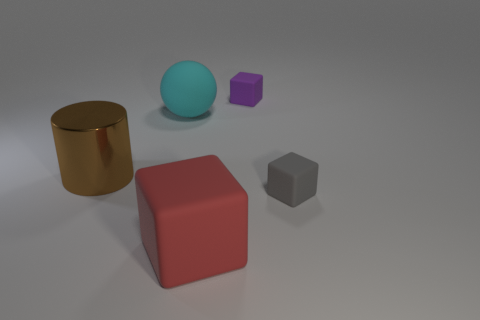Is there any other thing that has the same material as the large brown cylinder?
Make the answer very short. No. Is the object that is left of the big cyan rubber ball made of the same material as the big thing on the right side of the cyan rubber ball?
Provide a succinct answer. No. There is a matte thing that is on the left side of the small purple object and in front of the cylinder; how big is it?
Provide a succinct answer. Large. There is a brown object that is the same size as the cyan sphere; what is it made of?
Offer a very short reply. Metal. How many large cyan rubber balls are in front of the big rubber object that is in front of the big rubber thing behind the red matte thing?
Offer a very short reply. 0. What is the color of the big thing that is both right of the brown metallic cylinder and behind the big matte cube?
Keep it short and to the point. Cyan. What number of red matte cubes have the same size as the purple object?
Offer a terse response. 0. The large matte thing left of the block that is left of the purple thing is what shape?
Provide a short and direct response. Sphere. The matte object in front of the tiny rubber thing in front of the cube that is behind the gray rubber cube is what shape?
Offer a terse response. Cube. What number of tiny cyan matte things have the same shape as the gray object?
Provide a short and direct response. 0. 